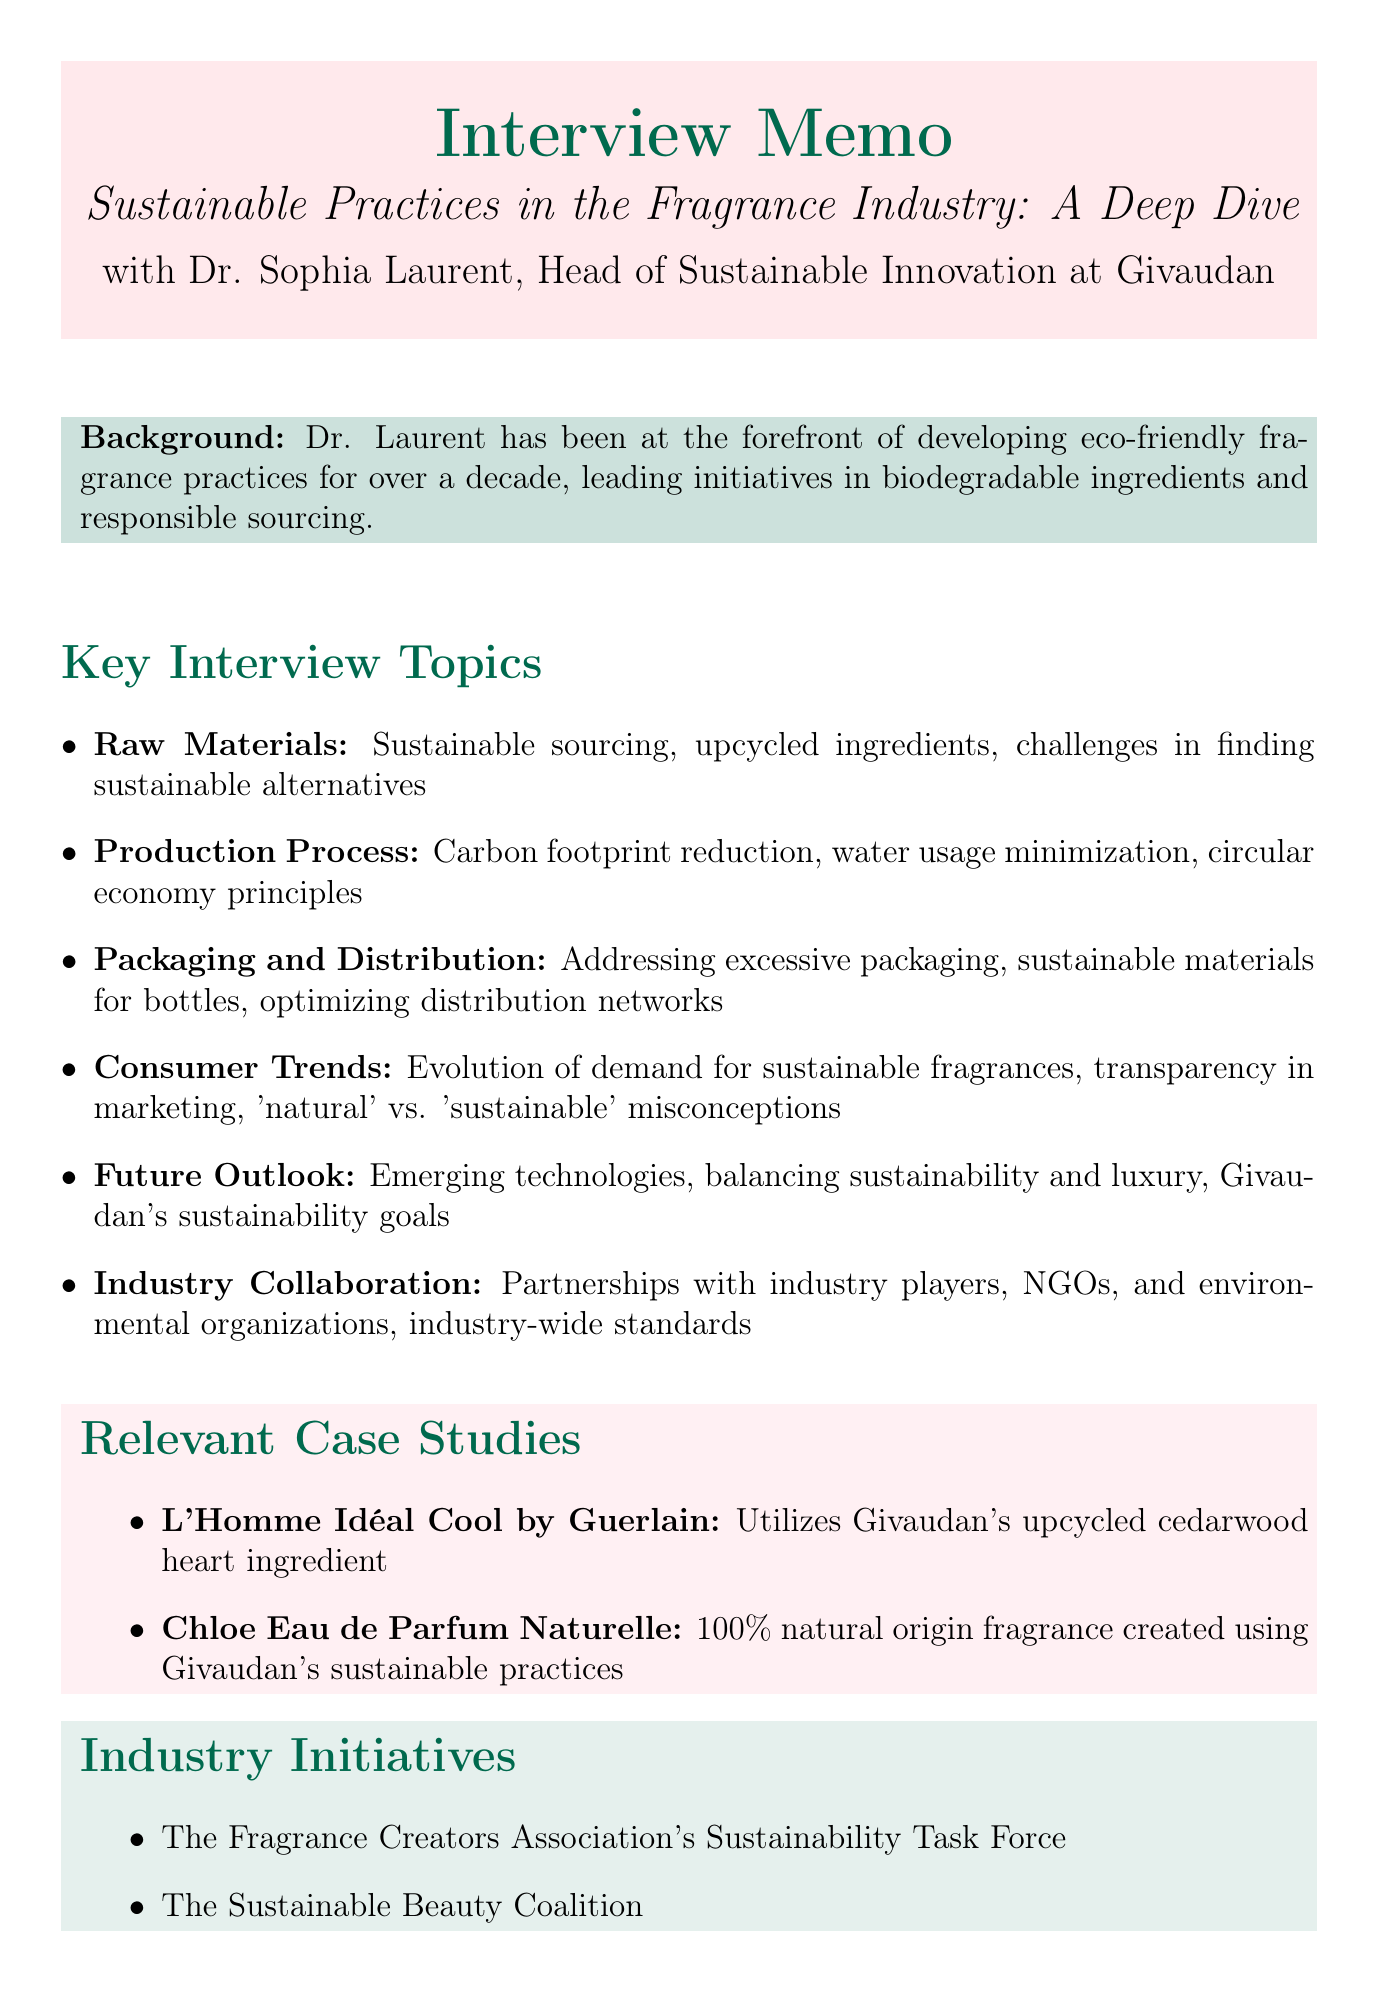What is the title of the interview? The title of the interview is stated at the beginning of the memo.
Answer: Sustainable Practices in the Fragrance Industry: A Deep Dive Who is the interviewee? The interviewee is introduced along with their position in the memo.
Answer: Dr. Sophia Laurent What is Dr. Laurent's position? Dr. Laurent's position is provided in her details section.
Answer: Head of Sustainable Innovation at Givaudan What is one relevant case study mentioned? The relevant case studies section lists fragrances that utilize sustainable practices.
Answer: L'Homme Idéal Cool by Guerlain What category addresses consumer trends? The categories are listed in the key interview topics section.
Answer: Consumer Trends Which industry initiative focuses on sustainability? The initiatives are listed towards the end of the memo.
Answer: The Fragrance Creators Association's Sustainability Task Force How many categories are there in the interview outline? The number of categories is derived from the key interview topics section.
Answer: Six What theme do the outlined questions related to "Production Process" cover? The questions in this category are summarized in the key interview topics section.
Answer: Carbon footprint reduction, water usage minimization, circular economy principles What organization's partnerships are mentioned for sustainability? The section on industry collaboration specifies organizations for partnerships.
Answer: NGOs or environmental organizations 